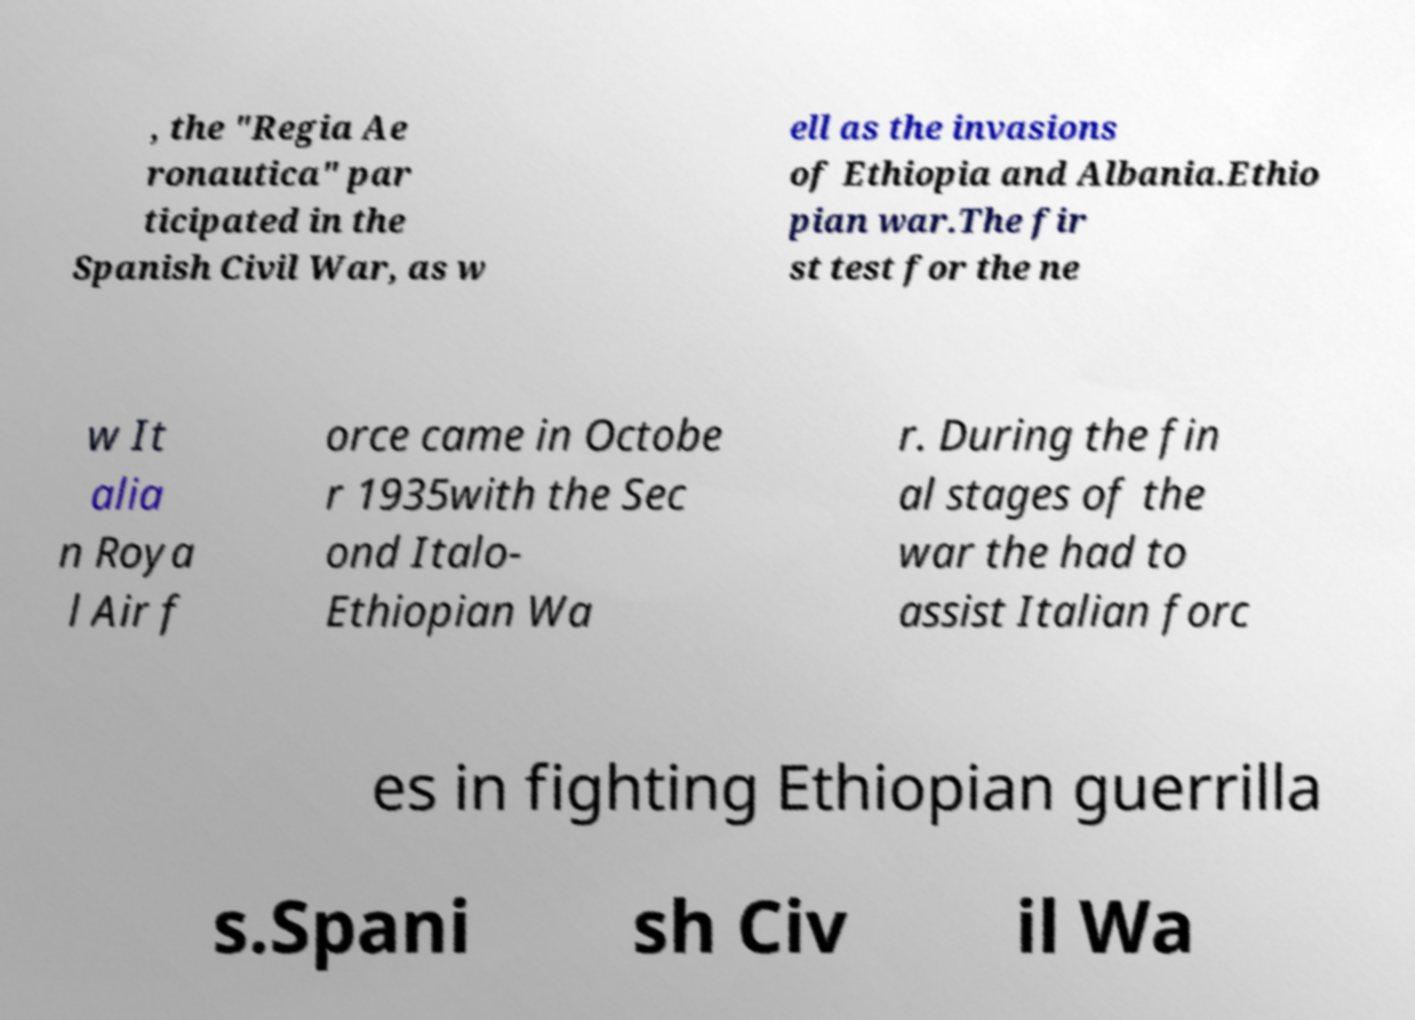Please read and relay the text visible in this image. What does it say? , the "Regia Ae ronautica" par ticipated in the Spanish Civil War, as w ell as the invasions of Ethiopia and Albania.Ethio pian war.The fir st test for the ne w It alia n Roya l Air f orce came in Octobe r 1935with the Sec ond Italo- Ethiopian Wa r. During the fin al stages of the war the had to assist Italian forc es in fighting Ethiopian guerrilla s.Spani sh Civ il Wa 